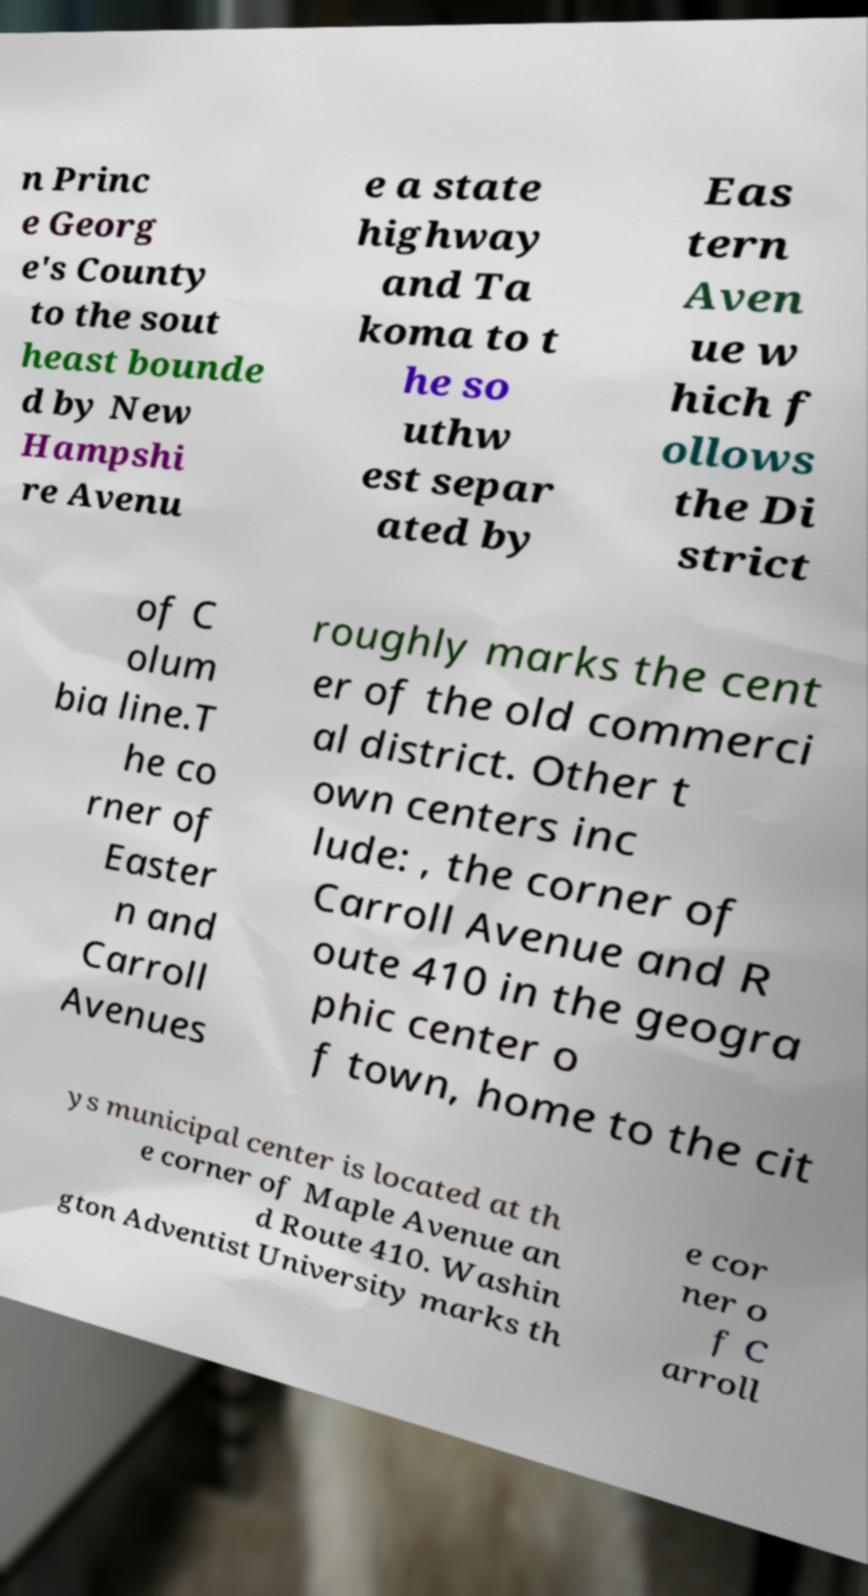Could you assist in decoding the text presented in this image and type it out clearly? n Princ e Georg e's County to the sout heast bounde d by New Hampshi re Avenu e a state highway and Ta koma to t he so uthw est separ ated by Eas tern Aven ue w hich f ollows the Di strict of C olum bia line.T he co rner of Easter n and Carroll Avenues roughly marks the cent er of the old commerci al district. Other t own centers inc lude: , the corner of Carroll Avenue and R oute 410 in the geogra phic center o f town, home to the cit ys municipal center is located at th e corner of Maple Avenue an d Route 410. Washin gton Adventist University marks th e cor ner o f C arroll 